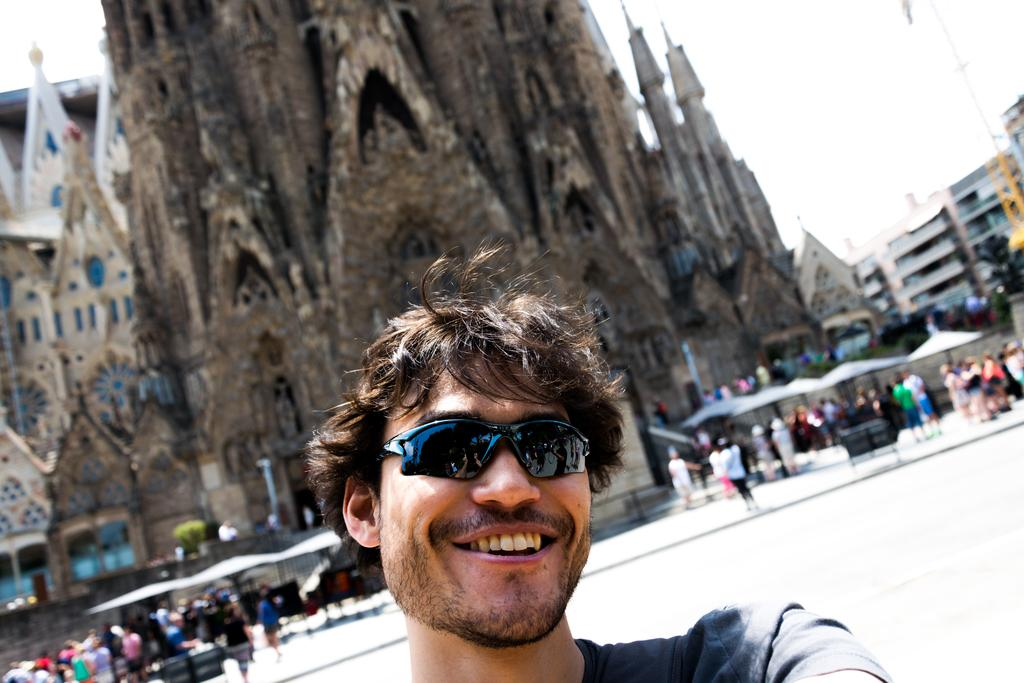What is the person in the image wearing? The person in the image is wearing cooling glasses. Can you describe the background of the image? There are people and buildings in the background of the image. How many teeth can be seen in the image? There are no teeth visible in the image. What is the emotional response of the person in the image towards the toes of the people in the background? The image does not provide any information about the person's emotional response or the presence of toes in the background. 